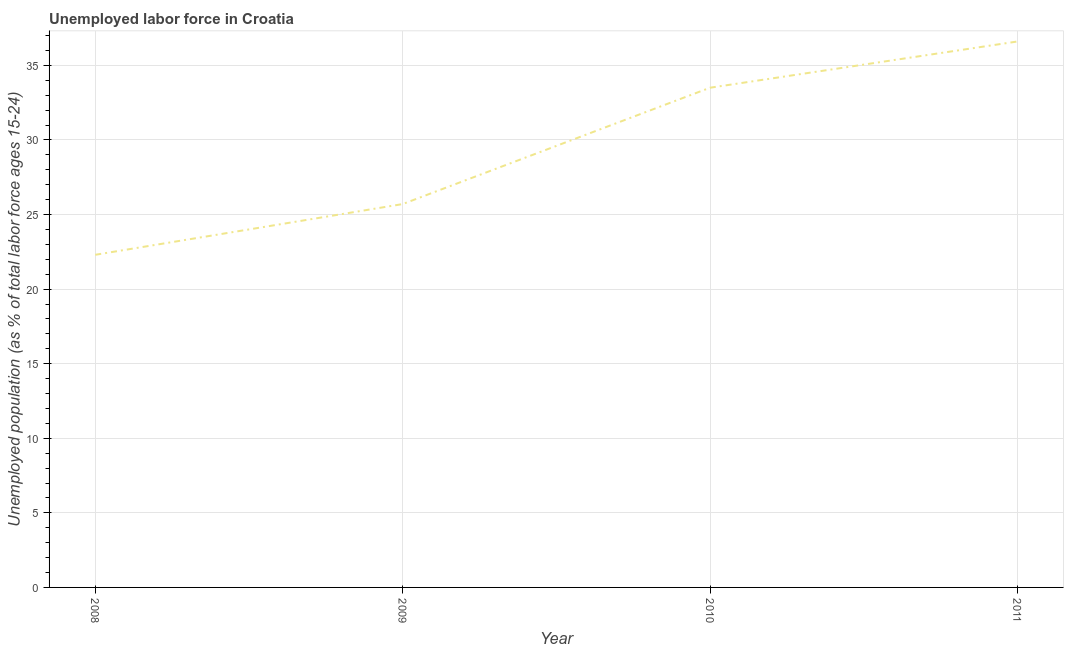What is the total unemployed youth population in 2011?
Keep it short and to the point. 36.6. Across all years, what is the maximum total unemployed youth population?
Your response must be concise. 36.6. Across all years, what is the minimum total unemployed youth population?
Give a very brief answer. 22.3. In which year was the total unemployed youth population maximum?
Keep it short and to the point. 2011. What is the sum of the total unemployed youth population?
Provide a short and direct response. 118.1. What is the difference between the total unemployed youth population in 2008 and 2011?
Keep it short and to the point. -14.3. What is the average total unemployed youth population per year?
Keep it short and to the point. 29.52. What is the median total unemployed youth population?
Keep it short and to the point. 29.6. In how many years, is the total unemployed youth population greater than 18 %?
Provide a succinct answer. 4. What is the ratio of the total unemployed youth population in 2010 to that in 2011?
Offer a terse response. 0.92. Is the total unemployed youth population in 2009 less than that in 2011?
Make the answer very short. Yes. What is the difference between the highest and the second highest total unemployed youth population?
Your answer should be very brief. 3.1. Is the sum of the total unemployed youth population in 2009 and 2010 greater than the maximum total unemployed youth population across all years?
Provide a succinct answer. Yes. What is the difference between the highest and the lowest total unemployed youth population?
Offer a terse response. 14.3. In how many years, is the total unemployed youth population greater than the average total unemployed youth population taken over all years?
Provide a short and direct response. 2. Does the total unemployed youth population monotonically increase over the years?
Provide a short and direct response. Yes. How many lines are there?
Make the answer very short. 1. Are the values on the major ticks of Y-axis written in scientific E-notation?
Offer a very short reply. No. Does the graph contain grids?
Keep it short and to the point. Yes. What is the title of the graph?
Keep it short and to the point. Unemployed labor force in Croatia. What is the label or title of the Y-axis?
Offer a terse response. Unemployed population (as % of total labor force ages 15-24). What is the Unemployed population (as % of total labor force ages 15-24) of 2008?
Offer a terse response. 22.3. What is the Unemployed population (as % of total labor force ages 15-24) in 2009?
Provide a succinct answer. 25.7. What is the Unemployed population (as % of total labor force ages 15-24) of 2010?
Offer a terse response. 33.5. What is the Unemployed population (as % of total labor force ages 15-24) of 2011?
Provide a short and direct response. 36.6. What is the difference between the Unemployed population (as % of total labor force ages 15-24) in 2008 and 2009?
Ensure brevity in your answer.  -3.4. What is the difference between the Unemployed population (as % of total labor force ages 15-24) in 2008 and 2011?
Provide a short and direct response. -14.3. What is the difference between the Unemployed population (as % of total labor force ages 15-24) in 2010 and 2011?
Your response must be concise. -3.1. What is the ratio of the Unemployed population (as % of total labor force ages 15-24) in 2008 to that in 2009?
Give a very brief answer. 0.87. What is the ratio of the Unemployed population (as % of total labor force ages 15-24) in 2008 to that in 2010?
Keep it short and to the point. 0.67. What is the ratio of the Unemployed population (as % of total labor force ages 15-24) in 2008 to that in 2011?
Make the answer very short. 0.61. What is the ratio of the Unemployed population (as % of total labor force ages 15-24) in 2009 to that in 2010?
Your answer should be very brief. 0.77. What is the ratio of the Unemployed population (as % of total labor force ages 15-24) in 2009 to that in 2011?
Offer a terse response. 0.7. What is the ratio of the Unemployed population (as % of total labor force ages 15-24) in 2010 to that in 2011?
Your answer should be compact. 0.92. 